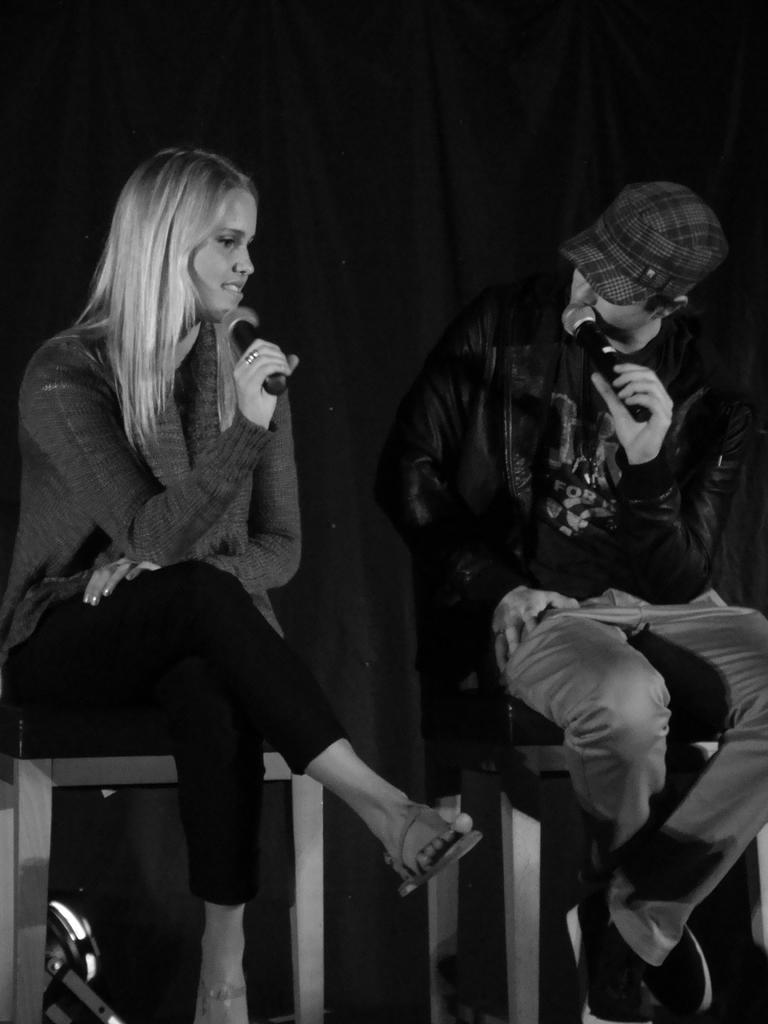How would you summarize this image in a sentence or two? In this image we can see two persons sitting on the chairs and they are holding the microphones. In the background, we can see the black curtain cloth. 